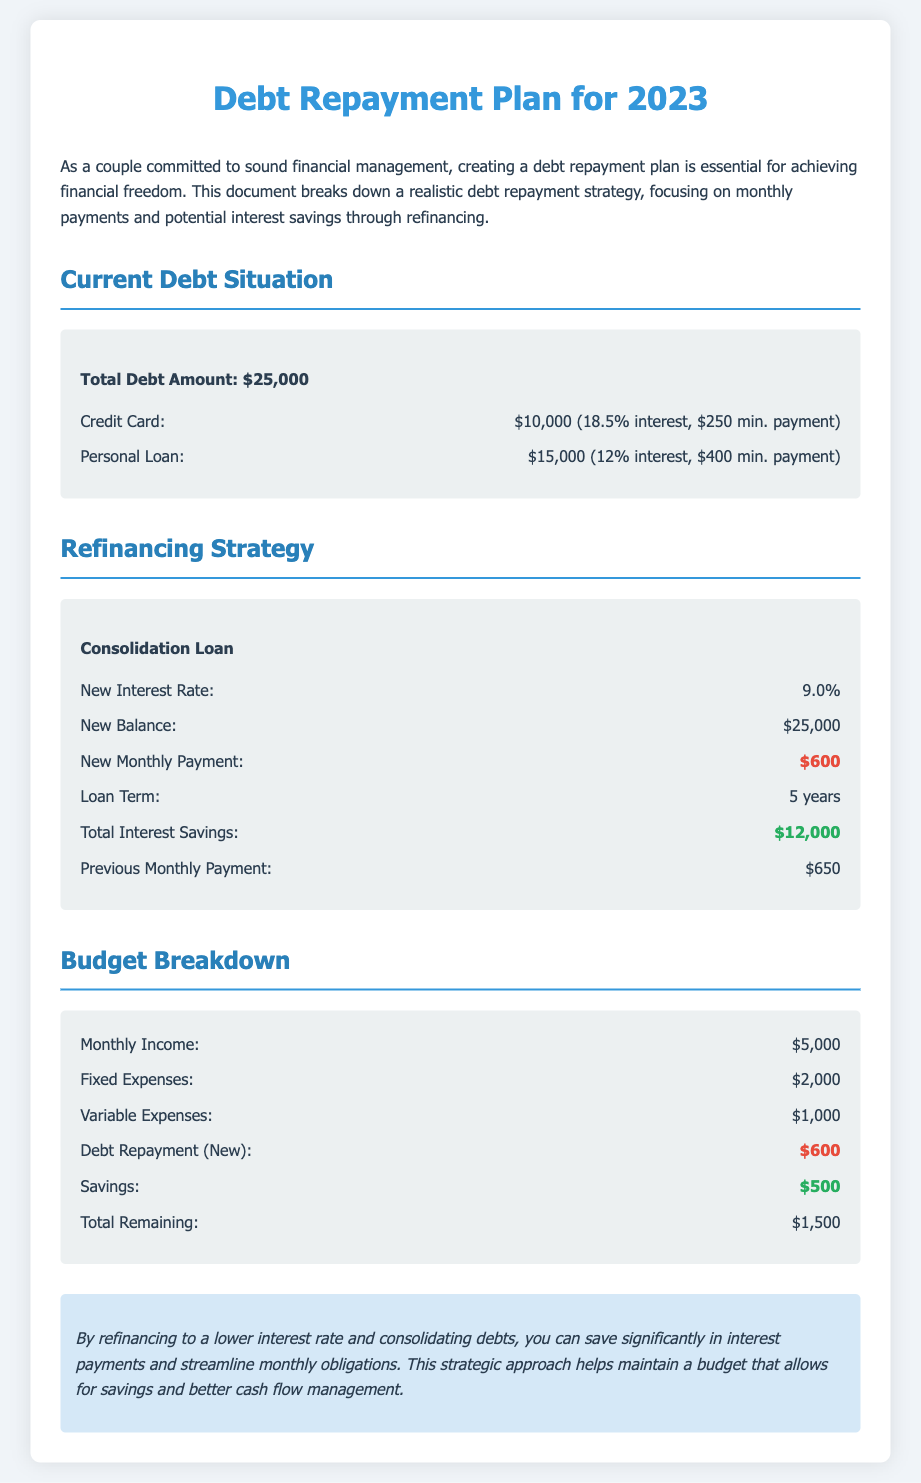what is the total debt amount? The total debt amount is stated in the document as the sum of all debts, which is $25,000.
Answer: $25,000 what is the interest rate of the credit card? The interest rate for the credit card debt is specified in the document as 18.5%.
Answer: 18.5% what will be the new monthly payment after refinancing? The new monthly payment is highlighted in the document as the amount required after refinancing, which is $600.
Answer: $600 how much will be saved in total interest from refinancing? The document specifies the total interest savings from refinancing, which is $12,000.
Answer: $12,000 what is the value of fixed expenses in the budget? The fixed expenses are mentioned in the budget breakdown as $2,000.
Answer: $2,000 what is the total remaining amount after expenses and debt repayment? The total remaining is calculated in the budget section as $1,500 after accounting for expenses and debt repayment.
Answer: $1,500 what is the total previous monthly payment before refinancing? The document states the previous monthly payment before refinancing as $650.
Answer: $650 how long will the loan term be after refinancing? The loan term is indicated in the refinancing strategy as 5 years.
Answer: 5 years what is the monthly income mentioned in the budget? Monthly income is provided in the budget section as $5,000.
Answer: $5,000 